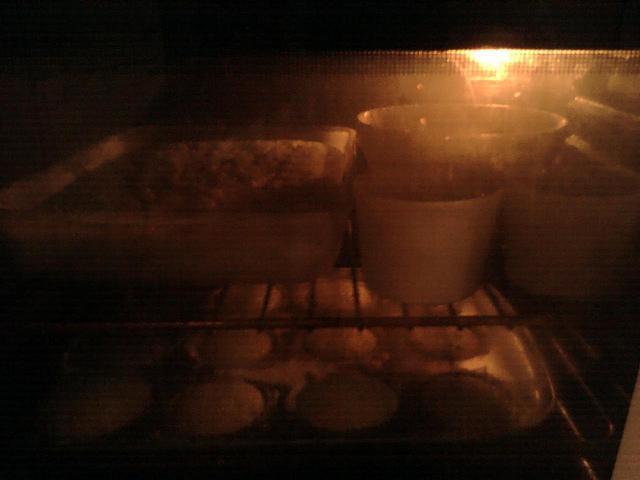How many layers is the cake?
Give a very brief answer. 1. How many bowls are there?
Give a very brief answer. 2. How many sandwiches are on the plate?
Give a very brief answer. 0. 